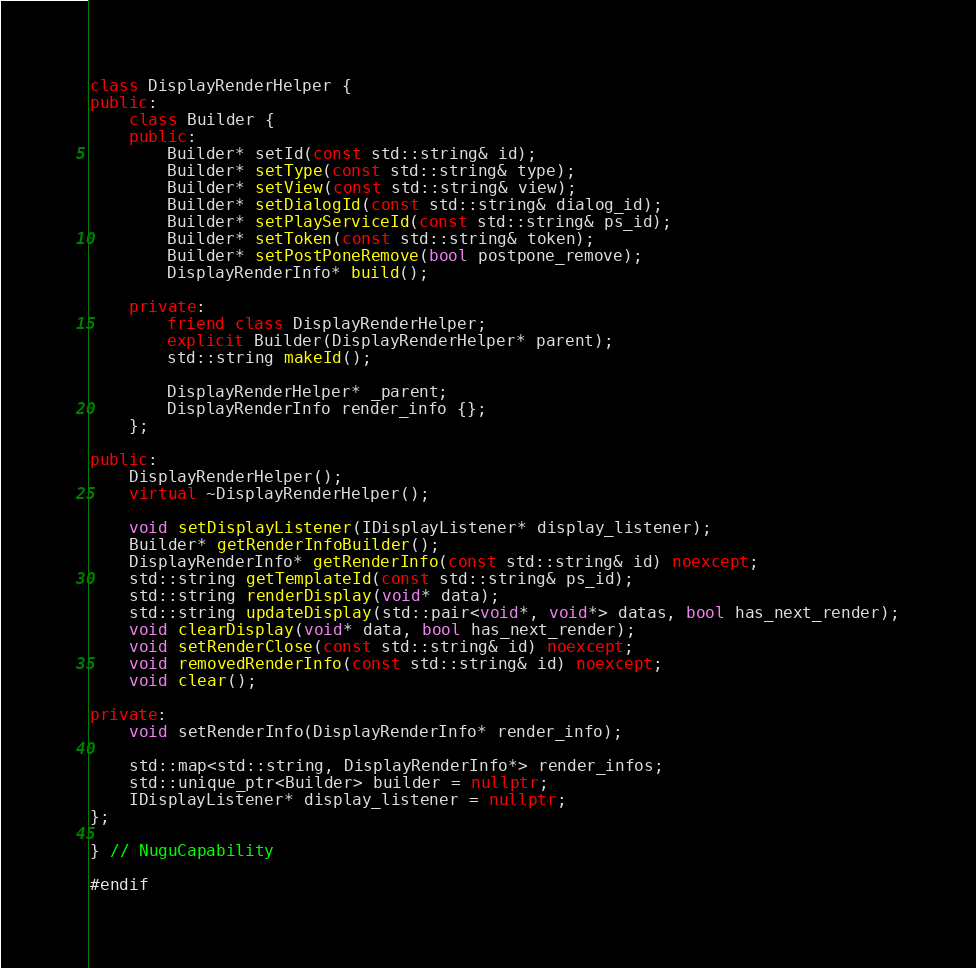<code> <loc_0><loc_0><loc_500><loc_500><_C++_>
class DisplayRenderHelper {
public:
    class Builder {
    public:
        Builder* setId(const std::string& id);
        Builder* setType(const std::string& type);
        Builder* setView(const std::string& view);
        Builder* setDialogId(const std::string& dialog_id);
        Builder* setPlayServiceId(const std::string& ps_id);
        Builder* setToken(const std::string& token);
        Builder* setPostPoneRemove(bool postpone_remove);
        DisplayRenderInfo* build();

    private:
        friend class DisplayRenderHelper;
        explicit Builder(DisplayRenderHelper* parent);
        std::string makeId();

        DisplayRenderHelper* _parent;
        DisplayRenderInfo render_info {};
    };

public:
    DisplayRenderHelper();
    virtual ~DisplayRenderHelper();

    void setDisplayListener(IDisplayListener* display_listener);
    Builder* getRenderInfoBuilder();
    DisplayRenderInfo* getRenderInfo(const std::string& id) noexcept;
    std::string getTemplateId(const std::string& ps_id);
    std::string renderDisplay(void* data);
    std::string updateDisplay(std::pair<void*, void*> datas, bool has_next_render);
    void clearDisplay(void* data, bool has_next_render);
    void setRenderClose(const std::string& id) noexcept;
    void removedRenderInfo(const std::string& id) noexcept;
    void clear();

private:
    void setRenderInfo(DisplayRenderInfo* render_info);

    std::map<std::string, DisplayRenderInfo*> render_infos;
    std::unique_ptr<Builder> builder = nullptr;
    IDisplayListener* display_listener = nullptr;
};

} // NuguCapability

#endif
</code> 